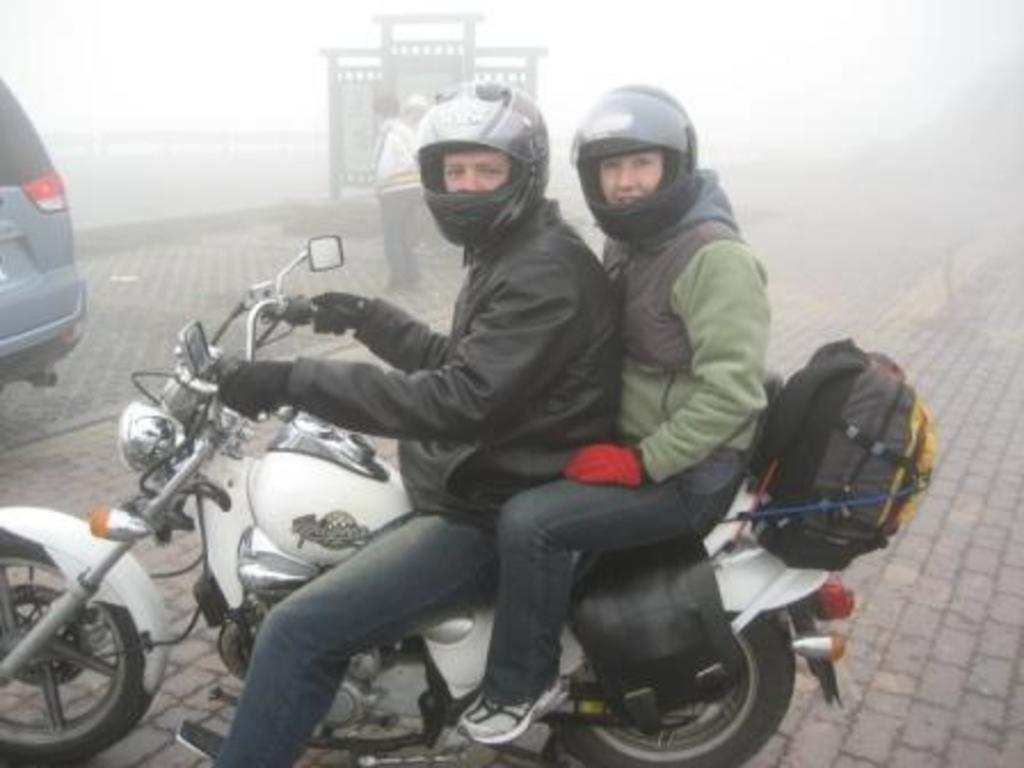How many people are in the image? There are two people in the image. What are the two people doing in the image? The two people are sitting on a white color bike. Can you describe the background of the image? The background of the image is blurred and foggy. What else can be seen in the image besides the people and the bike? There is a car on the left side of the image. What type of beam is holding up the street in the image? There is no street or beam present in the image; it features two people sitting on a bike with a car in the background. 